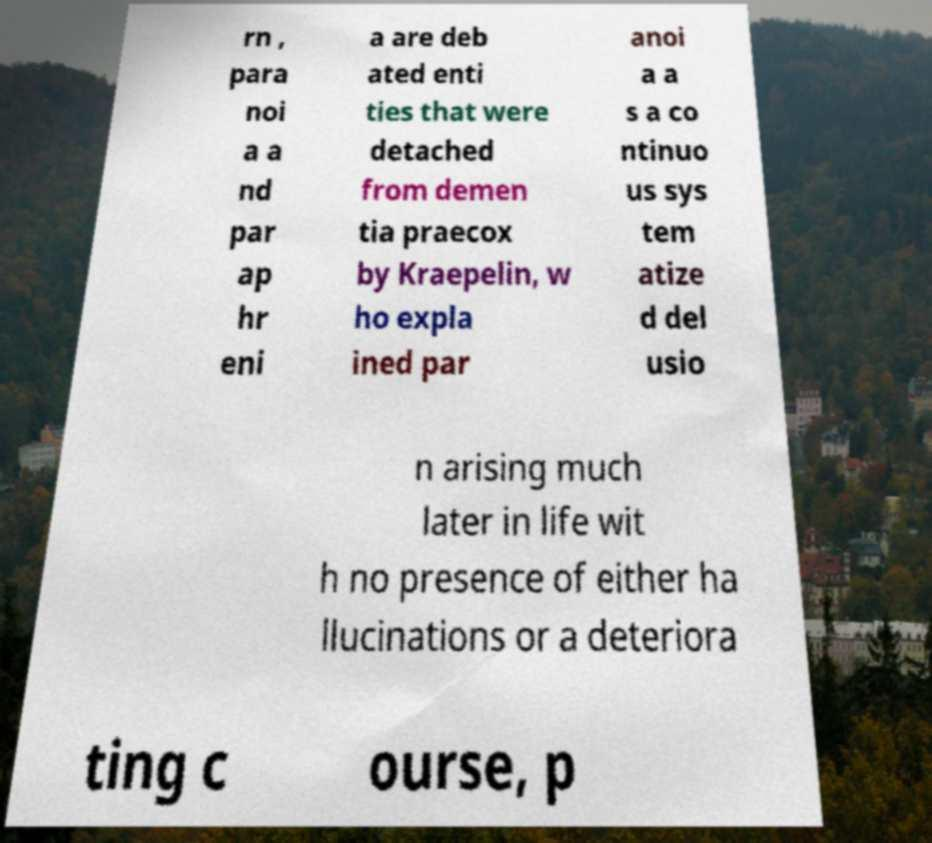Could you extract and type out the text from this image? rn , para noi a a nd par ap hr eni a are deb ated enti ties that were detached from demen tia praecox by Kraepelin, w ho expla ined par anoi a a s a co ntinuo us sys tem atize d del usio n arising much later in life wit h no presence of either ha llucinations or a deteriora ting c ourse, p 